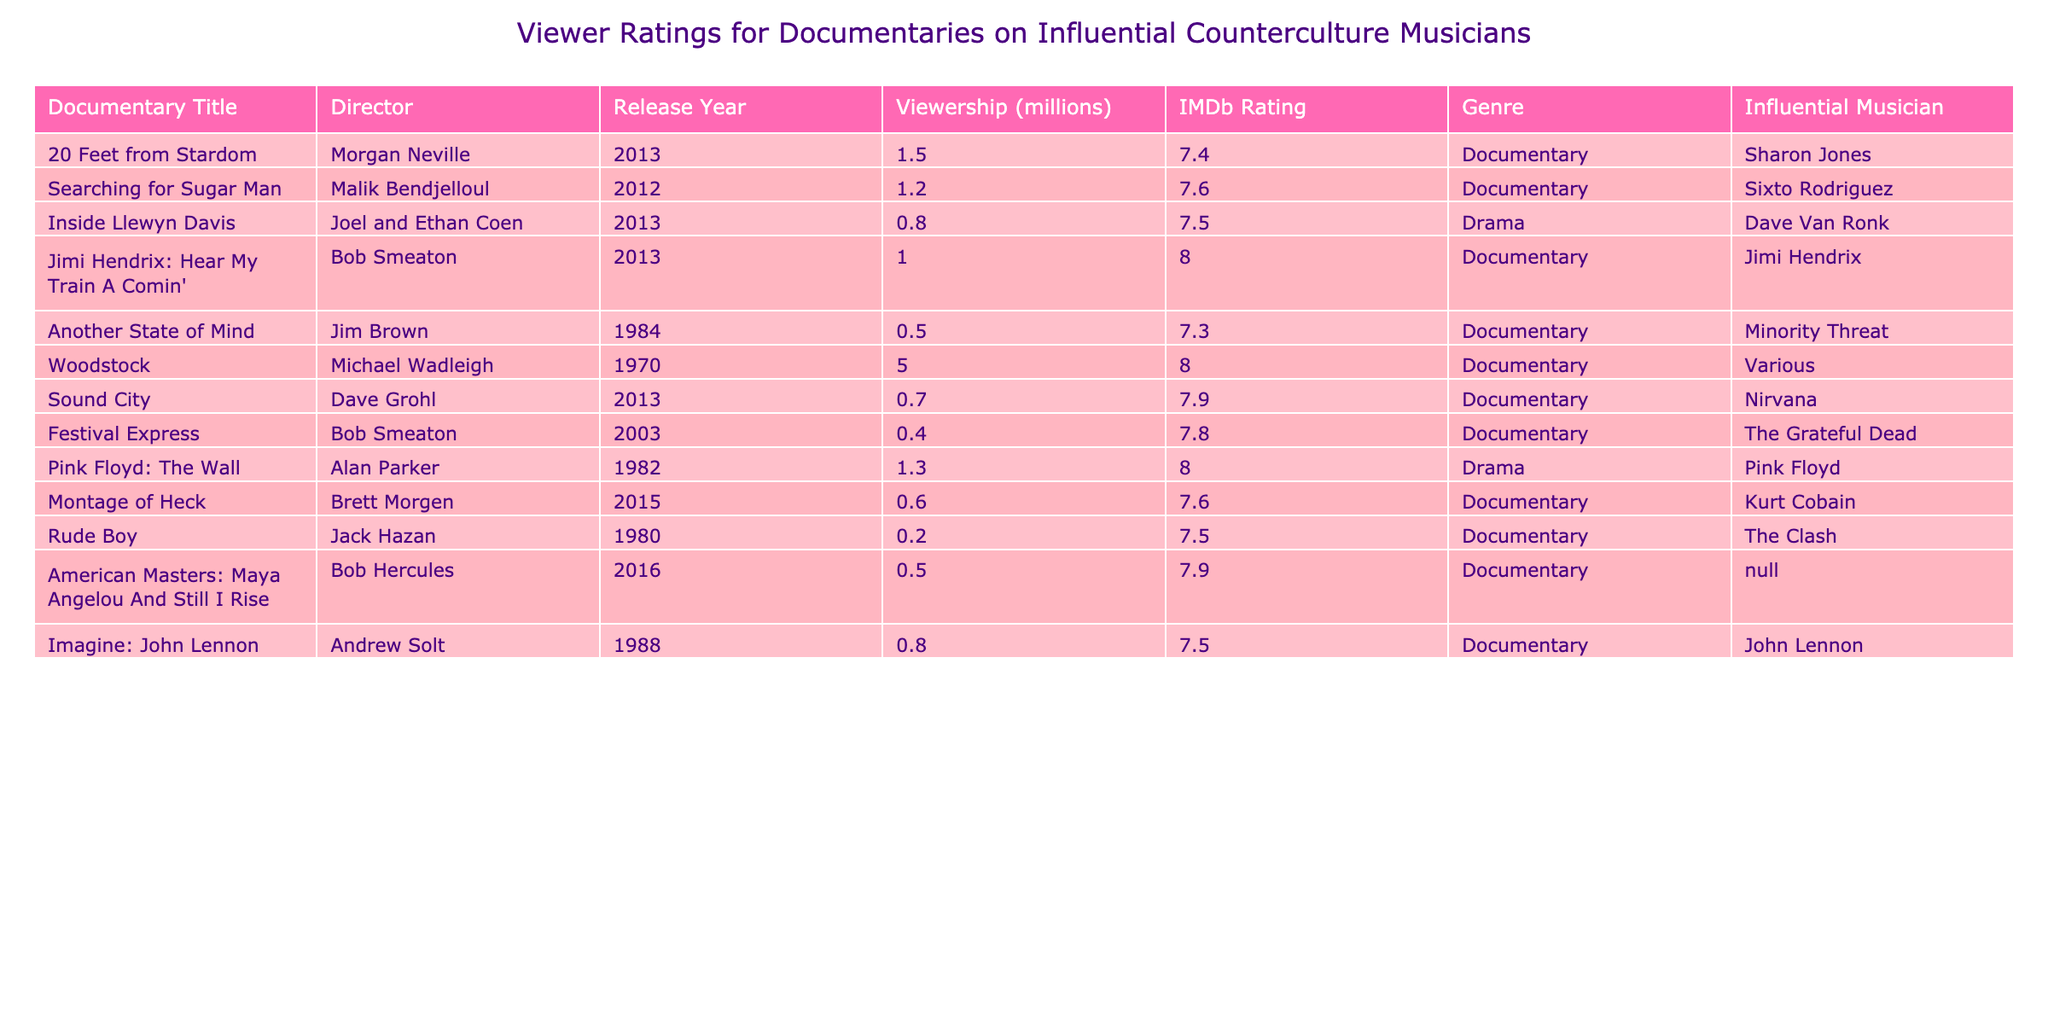What is the IMDb rating of "Searching for Sugar Man"? The table lists the IMDb rating for each documentary. Looking at the row for "Searching for Sugar Man," the rating is provided as 7.6.
Answer: 7.6 Which documentary has the highest viewership? The viewership for each documentary can be compared through their viewership numbers listed in the table. "Woodstock" has the highest viewership at 5.0 million.
Answer: 5.0 million How many documentaries have an IMDb rating of 8.0 or higher? To find the number of documentaries with an IMDb rating of 8.0 or higher, we count the rows where the rating is at least 8.0. The documentaries "Jimi Hendrix: Hear My Train A Comin'" and "Woodstock" meet this criterion, making a total of 2.
Answer: 2 What is the average viewership of all documentaries listed? To calculate the average viewership, we sum all the viewership numbers: 1.5 + 1.2 + 0.8 + 1.0 + 0.5 + 5.0 + 0.7 + 0.4 + 1.3 + 0.6 + 0.2 + 0.5 + 0.8 = 12.2 million across 13 documentaries, which gives an average of 12.2 / 13 = approximately 0.94.
Answer: 0.94 million Is "Rude Boy" directed by a well-known director? The table lists the director of "Rude Boy" as Jack Hazan, who is not as widely recognized as directors of some other documentaries listed, making this statement subjective. In general, Jack Hazan is less known compared to other directors like Bob Smeaton or Morgan Neville.
Answer: No Which influential musician has the lowest viewership according to the table? We need to look at the viewership data in the table. "Rude Boy," associated with The Clash, has the lowest viewership at 0.2 million.
Answer: The Clash How many documentaries were released after the year 2000? To find this, we count the documentaries released after 2000. The years listed are 2003 (1), 2012 (1), 2013 (3), and 2015 (1), totaling 6 documentaries.
Answer: 6 Does "Pink Floyd: The Wall" have an IMDb rating higher than "Montage of Heck"? Checking both IMDb ratings in the table, "Pink Floyd: The Wall" has a rating of 8.0, while "Montage of Heck" has a rating of 7.6. Since 8.0 is greater than 7.6, the answer is yes.
Answer: Yes What is the difference in viewership between "Woodstock" and "Another State of Mind"? The viewership of "Woodstock" is 5.0 million, and "Another State of Mind" is 0.5 million. Thus, the difference in their viewership is 5.0 - 0.5 = 4.5 million.
Answer: 4.5 million Which documentary genre has more documentaries based on the table? By analyzing the genre column, we can see there are 10 documentaries classified as Documentary and 3 as Drama. Therefore, the Documentary genre has more entries in the table.
Answer: Documentary Which influential musician is associated with the most recent documentary, based on the release year? The most recent documentary released in the table is "Montage of Heck" from 2015, which is associated with Kurt Cobain.
Answer: Kurt Cobain 